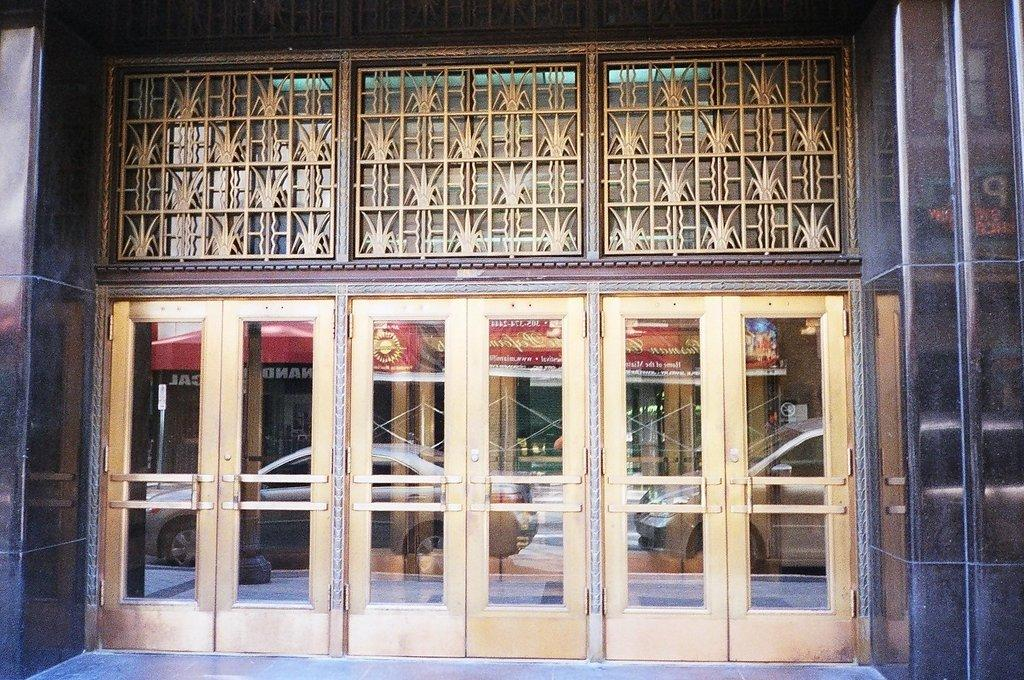What type of structure is in the image? There is a building in the image. What feature of the building is mentioned in the facts? The building has glass doors. What can be seen through the glass doors? Vehicles are visible through the glass doors. What else can be seen beyond the vehicles through the glass doors? There is at least one other building visible through the glass doors. What type of grain is being harvested in the image? There is no grain or harvesting activity present in the image; it features a building with glass doors. 